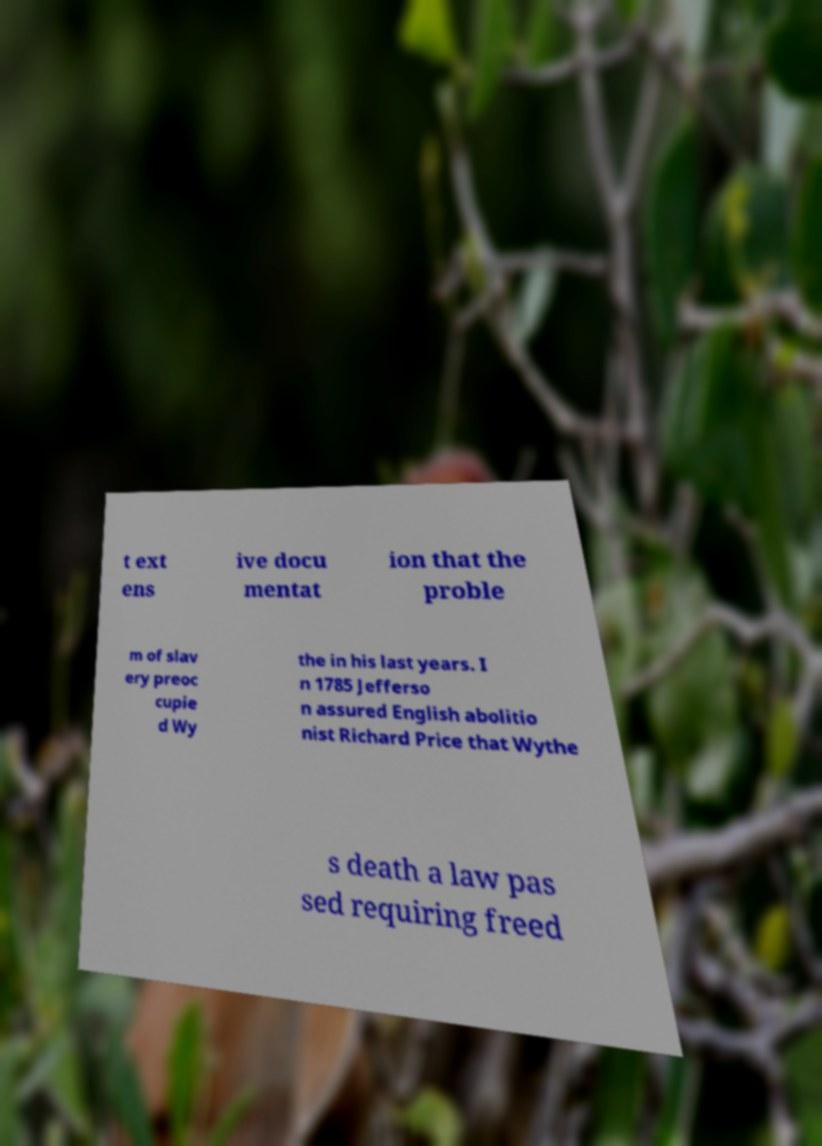Could you extract and type out the text from this image? t ext ens ive docu mentat ion that the proble m of slav ery preoc cupie d Wy the in his last years. I n 1785 Jefferso n assured English abolitio nist Richard Price that Wythe s death a law pas sed requiring freed 